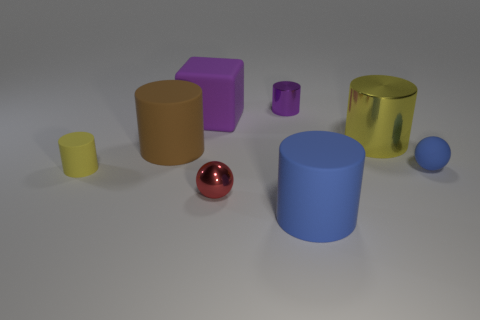There is another cylinder that is the same color as the tiny matte cylinder; what size is it?
Keep it short and to the point. Large. There is a metallic object that is the same color as the tiny matte cylinder; what is its shape?
Your answer should be compact. Cylinder. The small cylinder behind the big rubber cylinder left of the matte thing that is in front of the small matte cylinder is what color?
Give a very brief answer. Purple. What color is the metallic cylinder on the left side of the yellow object that is on the right side of the tiny purple metal cylinder?
Give a very brief answer. Purple. Are there more objects that are in front of the large purple object than tiny balls behind the purple cylinder?
Offer a terse response. Yes. Does the yellow cylinder on the right side of the blue cylinder have the same material as the purple thing to the left of the tiny purple cylinder?
Offer a very short reply. No. Are there any red metallic things in front of the red object?
Give a very brief answer. No. How many yellow things are small cylinders or tiny objects?
Give a very brief answer. 1. Are the big yellow thing and the tiny cylinder that is behind the tiny yellow cylinder made of the same material?
Your answer should be compact. Yes. What size is the yellow shiny object that is the same shape as the brown thing?
Your answer should be very brief. Large. 